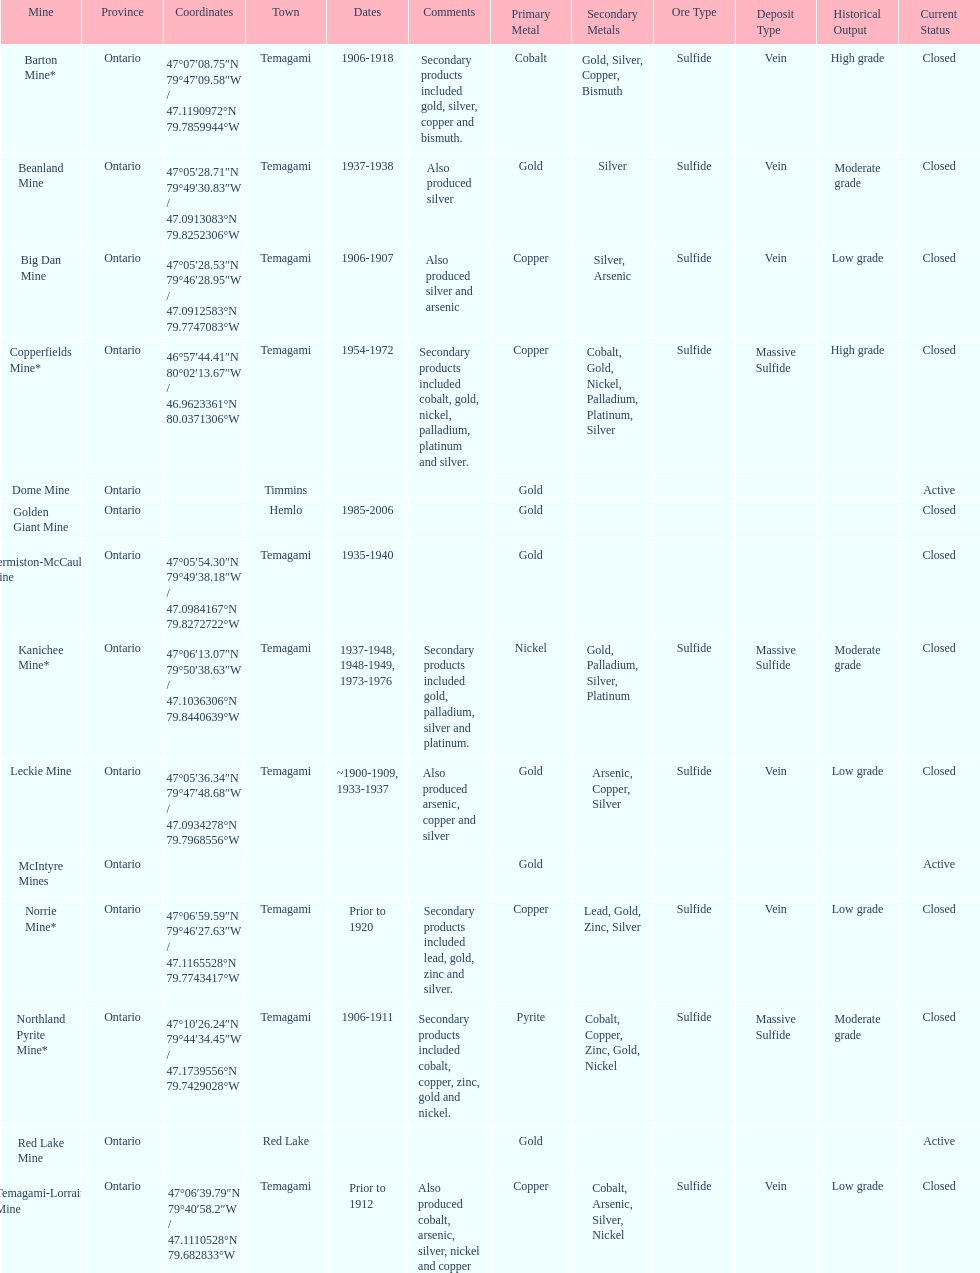How many mines were in temagami? 10. 